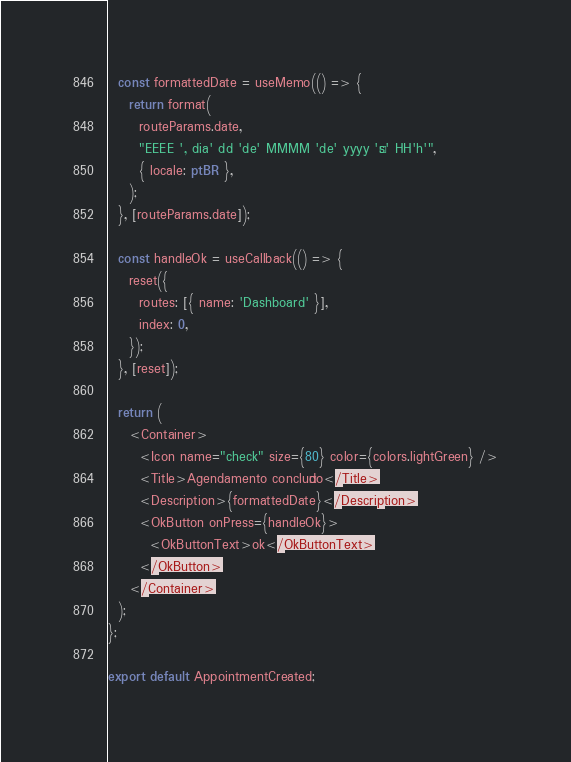<code> <loc_0><loc_0><loc_500><loc_500><_TypeScript_>  const formattedDate = useMemo(() => {
    return format(
      routeParams.date,
      "EEEE ', dia' dd 'de' MMMM 'de' yyyy 'às' HH'h'",
      { locale: ptBR },
    );
  }, [routeParams.date]);

  const handleOk = useCallback(() => {
    reset({
      routes: [{ name: 'Dashboard' }],
      index: 0,
    });
  }, [reset]);

  return (
    <Container>
      <Icon name="check" size={80} color={colors.lightGreen} />
      <Title>Agendamento concluído</Title>
      <Description>{formattedDate}</Description>
      <OkButton onPress={handleOk}>
        <OkButtonText>ok</OkButtonText>
      </OkButton>
    </Container>
  );
};

export default AppointmentCreated;
</code> 